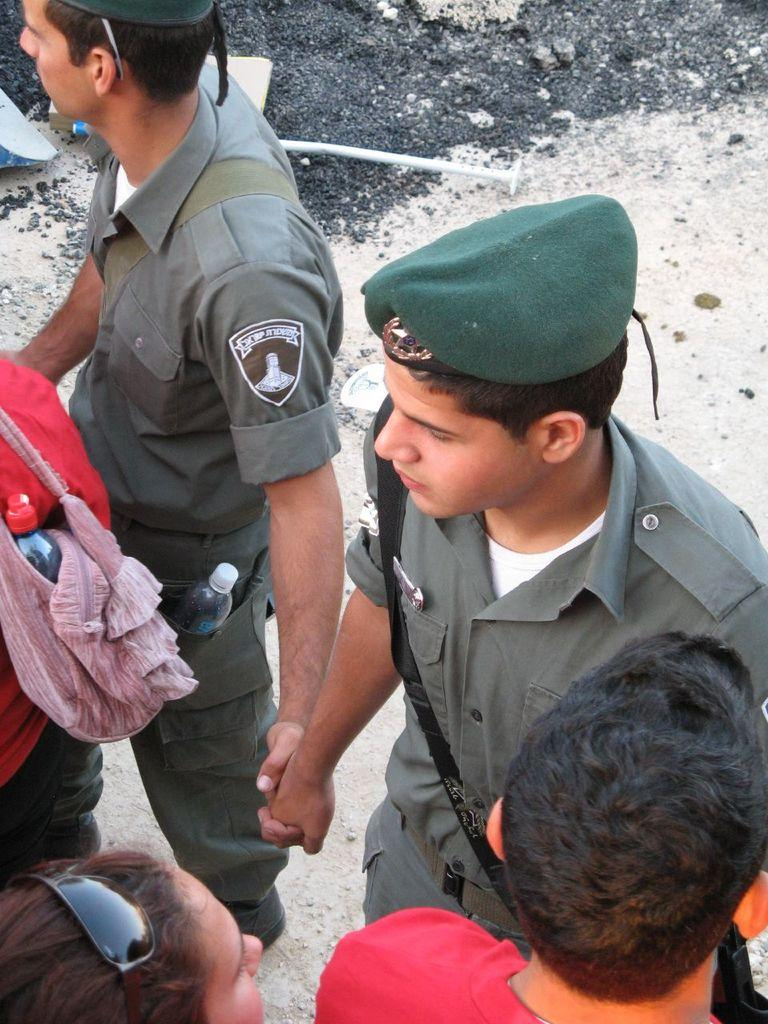What is happening in the image? There are people standing in the image. What objects can be seen near the people? There are two bottles visible in the image. Can you describe the clothing or accessories of any of the people? One person in the image is wearing a cap. What type of snakes can be seen slithering around the people in the image? There are no snakes present in the image; it only features people and bottles. 